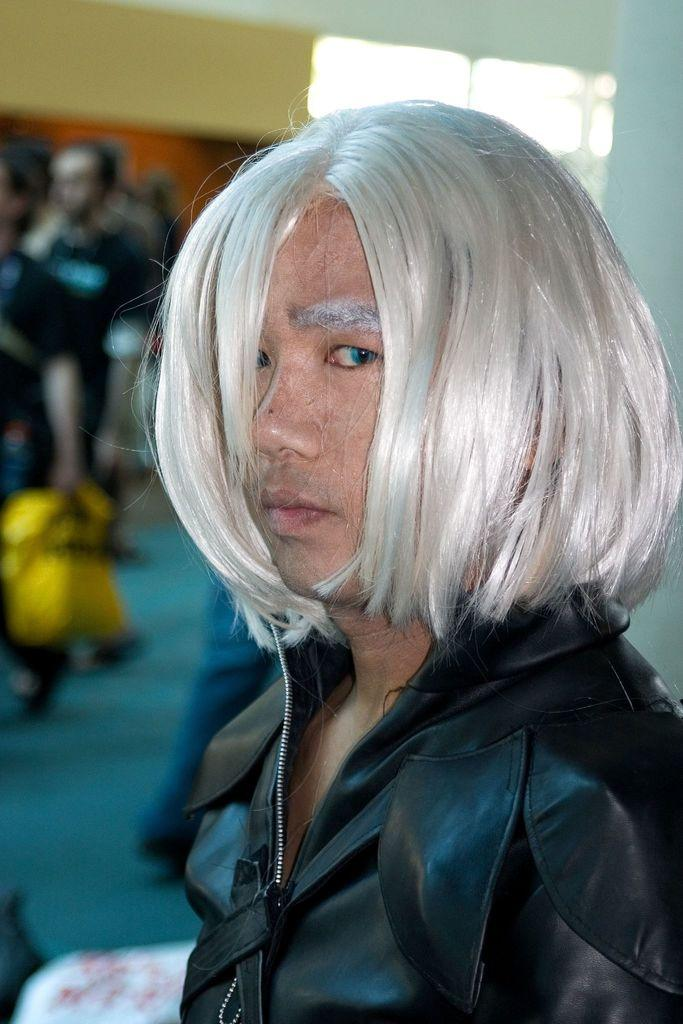What is the person in the image wearing? The person in the image is wearing a black dress. Can you describe the background of the image? There are people and a wall in the background of the image, and the background is blurred. What type of dinosaurs can be seen in the image? There are no dinosaurs present in the image. How does the person's health appear in the image? The image does not provide any information about the person's health. 